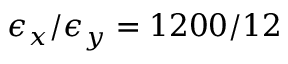Convert formula to latex. <formula><loc_0><loc_0><loc_500><loc_500>\epsilon _ { x } / \epsilon _ { y } = 1 2 0 0 / 1 2</formula> 